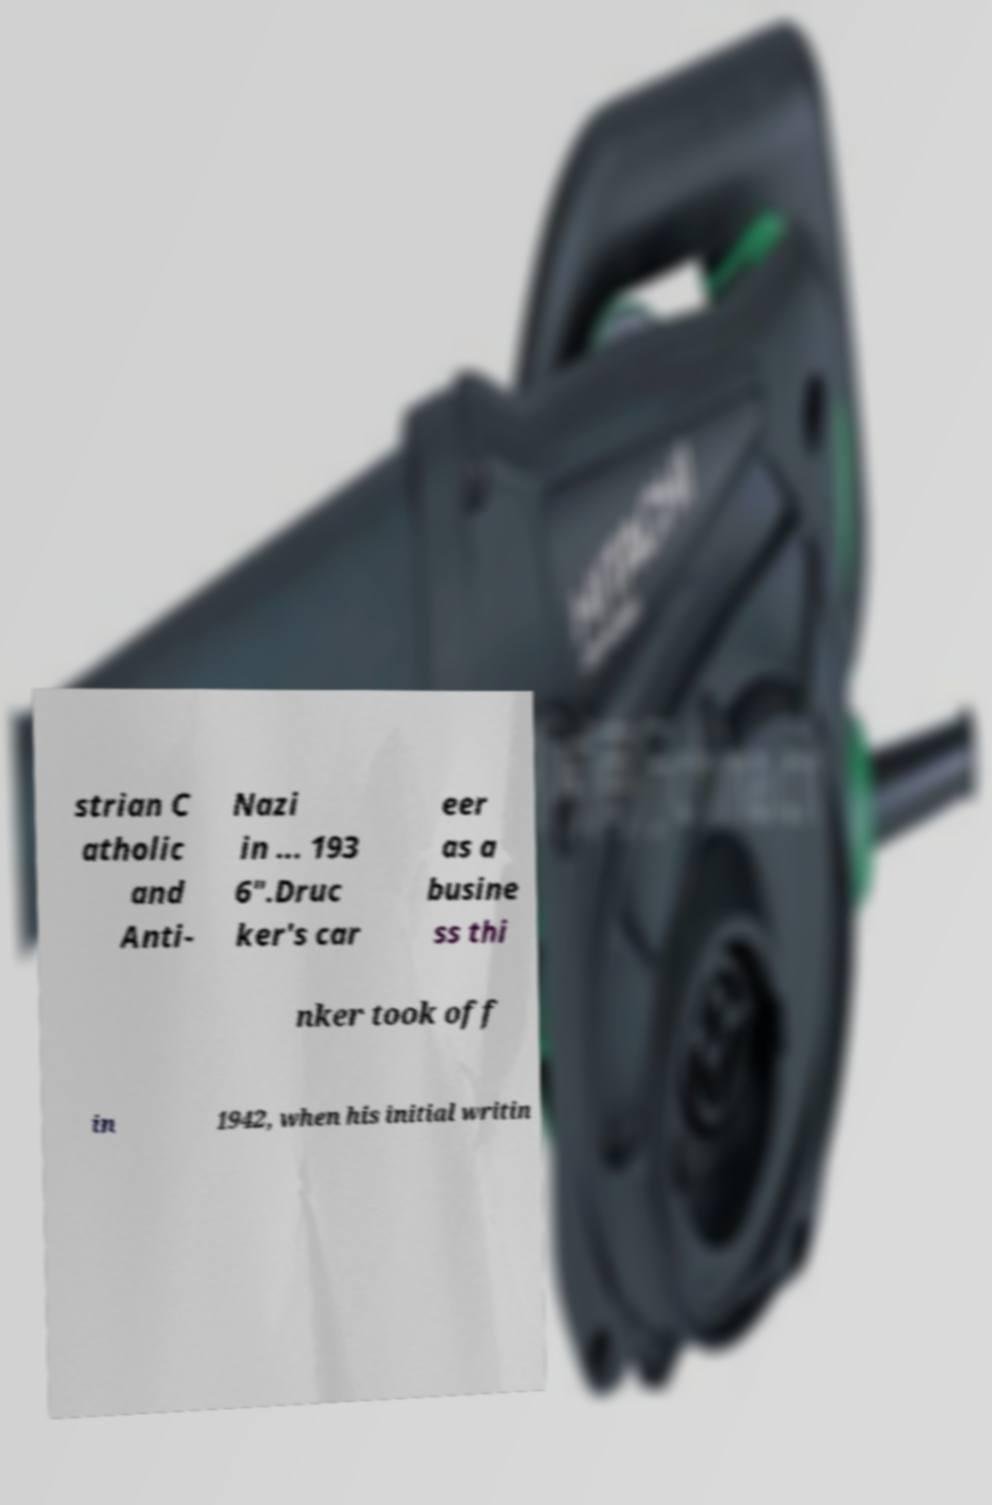Please read and relay the text visible in this image. What does it say? strian C atholic and Anti- Nazi in ... 193 6".Druc ker's car eer as a busine ss thi nker took off in 1942, when his initial writin 